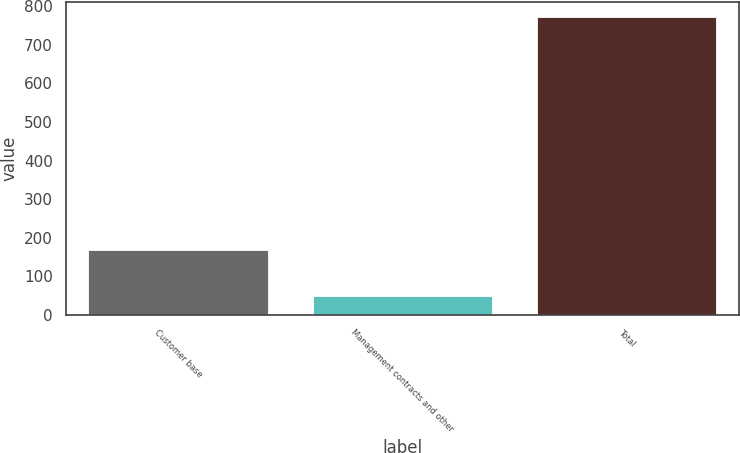<chart> <loc_0><loc_0><loc_500><loc_500><bar_chart><fcel>Customer base<fcel>Management contracts and other<fcel>Total<nl><fcel>166.6<fcel>49.3<fcel>773<nl></chart> 